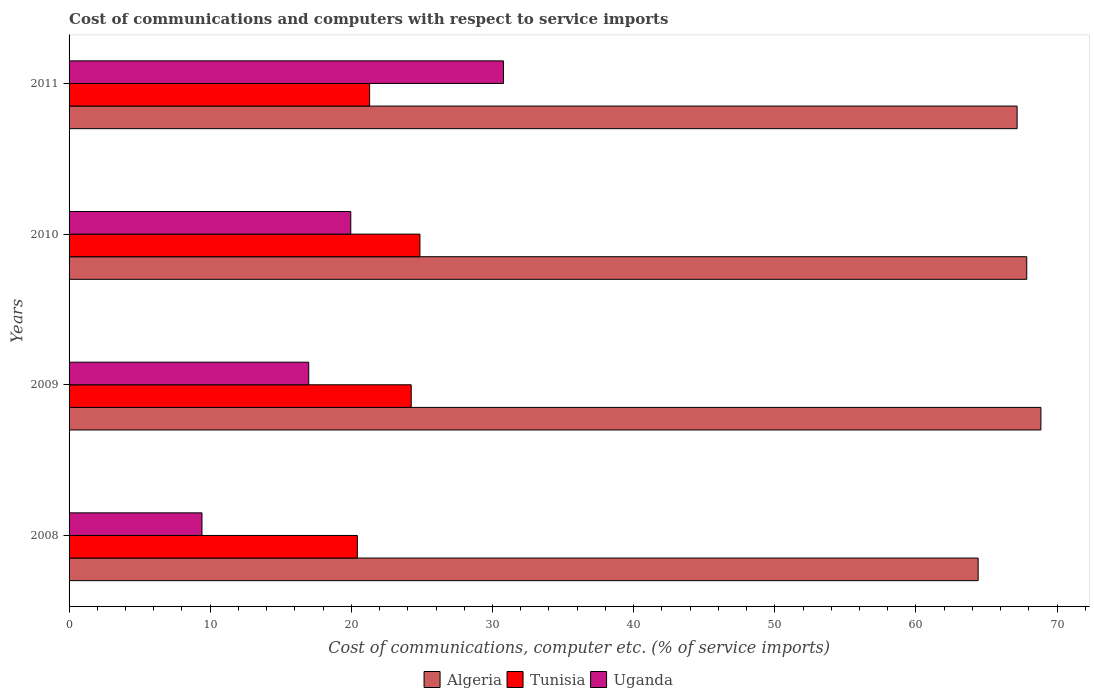How many groups of bars are there?
Your answer should be very brief. 4. How many bars are there on the 4th tick from the bottom?
Make the answer very short. 3. What is the label of the 2nd group of bars from the top?
Your answer should be very brief. 2010. What is the cost of communications and computers in Tunisia in 2011?
Give a very brief answer. 21.29. Across all years, what is the maximum cost of communications and computers in Uganda?
Keep it short and to the point. 30.78. Across all years, what is the minimum cost of communications and computers in Uganda?
Ensure brevity in your answer.  9.42. In which year was the cost of communications and computers in Tunisia maximum?
Provide a succinct answer. 2010. In which year was the cost of communications and computers in Tunisia minimum?
Offer a terse response. 2008. What is the total cost of communications and computers in Uganda in the graph?
Make the answer very short. 77.14. What is the difference between the cost of communications and computers in Tunisia in 2009 and that in 2011?
Provide a short and direct response. 2.95. What is the difference between the cost of communications and computers in Algeria in 2009 and the cost of communications and computers in Uganda in 2008?
Offer a very short reply. 59.44. What is the average cost of communications and computers in Uganda per year?
Your answer should be compact. 19.28. In the year 2011, what is the difference between the cost of communications and computers in Uganda and cost of communications and computers in Tunisia?
Ensure brevity in your answer.  9.48. What is the ratio of the cost of communications and computers in Tunisia in 2008 to that in 2010?
Offer a terse response. 0.82. What is the difference between the highest and the second highest cost of communications and computers in Algeria?
Make the answer very short. 1. What is the difference between the highest and the lowest cost of communications and computers in Algeria?
Give a very brief answer. 4.45. In how many years, is the cost of communications and computers in Algeria greater than the average cost of communications and computers in Algeria taken over all years?
Offer a very short reply. 3. What does the 1st bar from the top in 2009 represents?
Offer a terse response. Uganda. What does the 2nd bar from the bottom in 2009 represents?
Offer a terse response. Tunisia. Is it the case that in every year, the sum of the cost of communications and computers in Algeria and cost of communications and computers in Tunisia is greater than the cost of communications and computers in Uganda?
Your answer should be compact. Yes. Are all the bars in the graph horizontal?
Provide a succinct answer. Yes. How many years are there in the graph?
Offer a very short reply. 4. How many legend labels are there?
Your response must be concise. 3. What is the title of the graph?
Your answer should be very brief. Cost of communications and computers with respect to service imports. What is the label or title of the X-axis?
Make the answer very short. Cost of communications, computer etc. (% of service imports). What is the Cost of communications, computer etc. (% of service imports) of Algeria in 2008?
Provide a short and direct response. 64.41. What is the Cost of communications, computer etc. (% of service imports) of Tunisia in 2008?
Offer a very short reply. 20.42. What is the Cost of communications, computer etc. (% of service imports) of Uganda in 2008?
Your answer should be very brief. 9.42. What is the Cost of communications, computer etc. (% of service imports) in Algeria in 2009?
Provide a short and direct response. 68.86. What is the Cost of communications, computer etc. (% of service imports) of Tunisia in 2009?
Provide a succinct answer. 24.24. What is the Cost of communications, computer etc. (% of service imports) in Uganda in 2009?
Provide a short and direct response. 16.98. What is the Cost of communications, computer etc. (% of service imports) of Algeria in 2010?
Keep it short and to the point. 67.85. What is the Cost of communications, computer etc. (% of service imports) of Tunisia in 2010?
Keep it short and to the point. 24.86. What is the Cost of communications, computer etc. (% of service imports) of Uganda in 2010?
Provide a succinct answer. 19.96. What is the Cost of communications, computer etc. (% of service imports) of Algeria in 2011?
Your answer should be very brief. 67.17. What is the Cost of communications, computer etc. (% of service imports) of Tunisia in 2011?
Make the answer very short. 21.29. What is the Cost of communications, computer etc. (% of service imports) of Uganda in 2011?
Your answer should be very brief. 30.78. Across all years, what is the maximum Cost of communications, computer etc. (% of service imports) of Algeria?
Your response must be concise. 68.86. Across all years, what is the maximum Cost of communications, computer etc. (% of service imports) of Tunisia?
Your answer should be very brief. 24.86. Across all years, what is the maximum Cost of communications, computer etc. (% of service imports) of Uganda?
Your answer should be compact. 30.78. Across all years, what is the minimum Cost of communications, computer etc. (% of service imports) in Algeria?
Offer a terse response. 64.41. Across all years, what is the minimum Cost of communications, computer etc. (% of service imports) of Tunisia?
Offer a terse response. 20.42. Across all years, what is the minimum Cost of communications, computer etc. (% of service imports) in Uganda?
Offer a terse response. 9.42. What is the total Cost of communications, computer etc. (% of service imports) in Algeria in the graph?
Give a very brief answer. 268.29. What is the total Cost of communications, computer etc. (% of service imports) in Tunisia in the graph?
Provide a short and direct response. 90.82. What is the total Cost of communications, computer etc. (% of service imports) of Uganda in the graph?
Offer a terse response. 77.14. What is the difference between the Cost of communications, computer etc. (% of service imports) of Algeria in 2008 and that in 2009?
Provide a succinct answer. -4.45. What is the difference between the Cost of communications, computer etc. (% of service imports) of Tunisia in 2008 and that in 2009?
Make the answer very short. -3.82. What is the difference between the Cost of communications, computer etc. (% of service imports) of Uganda in 2008 and that in 2009?
Ensure brevity in your answer.  -7.56. What is the difference between the Cost of communications, computer etc. (% of service imports) in Algeria in 2008 and that in 2010?
Your response must be concise. -3.44. What is the difference between the Cost of communications, computer etc. (% of service imports) in Tunisia in 2008 and that in 2010?
Your answer should be compact. -4.43. What is the difference between the Cost of communications, computer etc. (% of service imports) of Uganda in 2008 and that in 2010?
Give a very brief answer. -10.54. What is the difference between the Cost of communications, computer etc. (% of service imports) of Algeria in 2008 and that in 2011?
Give a very brief answer. -2.76. What is the difference between the Cost of communications, computer etc. (% of service imports) of Tunisia in 2008 and that in 2011?
Provide a succinct answer. -0.87. What is the difference between the Cost of communications, computer etc. (% of service imports) in Uganda in 2008 and that in 2011?
Make the answer very short. -21.36. What is the difference between the Cost of communications, computer etc. (% of service imports) of Tunisia in 2009 and that in 2010?
Your answer should be very brief. -0.62. What is the difference between the Cost of communications, computer etc. (% of service imports) of Uganda in 2009 and that in 2010?
Your answer should be compact. -2.98. What is the difference between the Cost of communications, computer etc. (% of service imports) in Algeria in 2009 and that in 2011?
Ensure brevity in your answer.  1.69. What is the difference between the Cost of communications, computer etc. (% of service imports) of Tunisia in 2009 and that in 2011?
Make the answer very short. 2.95. What is the difference between the Cost of communications, computer etc. (% of service imports) of Uganda in 2009 and that in 2011?
Provide a succinct answer. -13.8. What is the difference between the Cost of communications, computer etc. (% of service imports) in Algeria in 2010 and that in 2011?
Your answer should be compact. 0.68. What is the difference between the Cost of communications, computer etc. (% of service imports) of Tunisia in 2010 and that in 2011?
Offer a terse response. 3.57. What is the difference between the Cost of communications, computer etc. (% of service imports) of Uganda in 2010 and that in 2011?
Provide a succinct answer. -10.82. What is the difference between the Cost of communications, computer etc. (% of service imports) in Algeria in 2008 and the Cost of communications, computer etc. (% of service imports) in Tunisia in 2009?
Make the answer very short. 40.17. What is the difference between the Cost of communications, computer etc. (% of service imports) in Algeria in 2008 and the Cost of communications, computer etc. (% of service imports) in Uganda in 2009?
Make the answer very short. 47.43. What is the difference between the Cost of communications, computer etc. (% of service imports) of Tunisia in 2008 and the Cost of communications, computer etc. (% of service imports) of Uganda in 2009?
Provide a succinct answer. 3.44. What is the difference between the Cost of communications, computer etc. (% of service imports) in Algeria in 2008 and the Cost of communications, computer etc. (% of service imports) in Tunisia in 2010?
Give a very brief answer. 39.55. What is the difference between the Cost of communications, computer etc. (% of service imports) in Algeria in 2008 and the Cost of communications, computer etc. (% of service imports) in Uganda in 2010?
Ensure brevity in your answer.  44.45. What is the difference between the Cost of communications, computer etc. (% of service imports) of Tunisia in 2008 and the Cost of communications, computer etc. (% of service imports) of Uganda in 2010?
Provide a succinct answer. 0.47. What is the difference between the Cost of communications, computer etc. (% of service imports) of Algeria in 2008 and the Cost of communications, computer etc. (% of service imports) of Tunisia in 2011?
Make the answer very short. 43.12. What is the difference between the Cost of communications, computer etc. (% of service imports) of Algeria in 2008 and the Cost of communications, computer etc. (% of service imports) of Uganda in 2011?
Make the answer very short. 33.63. What is the difference between the Cost of communications, computer etc. (% of service imports) in Tunisia in 2008 and the Cost of communications, computer etc. (% of service imports) in Uganda in 2011?
Offer a very short reply. -10.35. What is the difference between the Cost of communications, computer etc. (% of service imports) of Algeria in 2009 and the Cost of communications, computer etc. (% of service imports) of Tunisia in 2010?
Offer a very short reply. 44. What is the difference between the Cost of communications, computer etc. (% of service imports) in Algeria in 2009 and the Cost of communications, computer etc. (% of service imports) in Uganda in 2010?
Your response must be concise. 48.9. What is the difference between the Cost of communications, computer etc. (% of service imports) in Tunisia in 2009 and the Cost of communications, computer etc. (% of service imports) in Uganda in 2010?
Provide a succinct answer. 4.28. What is the difference between the Cost of communications, computer etc. (% of service imports) of Algeria in 2009 and the Cost of communications, computer etc. (% of service imports) of Tunisia in 2011?
Make the answer very short. 47.56. What is the difference between the Cost of communications, computer etc. (% of service imports) in Algeria in 2009 and the Cost of communications, computer etc. (% of service imports) in Uganda in 2011?
Keep it short and to the point. 38.08. What is the difference between the Cost of communications, computer etc. (% of service imports) in Tunisia in 2009 and the Cost of communications, computer etc. (% of service imports) in Uganda in 2011?
Keep it short and to the point. -6.54. What is the difference between the Cost of communications, computer etc. (% of service imports) of Algeria in 2010 and the Cost of communications, computer etc. (% of service imports) of Tunisia in 2011?
Ensure brevity in your answer.  46.56. What is the difference between the Cost of communications, computer etc. (% of service imports) of Algeria in 2010 and the Cost of communications, computer etc. (% of service imports) of Uganda in 2011?
Provide a succinct answer. 37.07. What is the difference between the Cost of communications, computer etc. (% of service imports) of Tunisia in 2010 and the Cost of communications, computer etc. (% of service imports) of Uganda in 2011?
Provide a short and direct response. -5.92. What is the average Cost of communications, computer etc. (% of service imports) of Algeria per year?
Your answer should be very brief. 67.07. What is the average Cost of communications, computer etc. (% of service imports) in Tunisia per year?
Your answer should be compact. 22.7. What is the average Cost of communications, computer etc. (% of service imports) in Uganda per year?
Ensure brevity in your answer.  19.28. In the year 2008, what is the difference between the Cost of communications, computer etc. (% of service imports) in Algeria and Cost of communications, computer etc. (% of service imports) in Tunisia?
Keep it short and to the point. 43.98. In the year 2008, what is the difference between the Cost of communications, computer etc. (% of service imports) of Algeria and Cost of communications, computer etc. (% of service imports) of Uganda?
Offer a terse response. 54.99. In the year 2008, what is the difference between the Cost of communications, computer etc. (% of service imports) in Tunisia and Cost of communications, computer etc. (% of service imports) in Uganda?
Make the answer very short. 11.01. In the year 2009, what is the difference between the Cost of communications, computer etc. (% of service imports) in Algeria and Cost of communications, computer etc. (% of service imports) in Tunisia?
Give a very brief answer. 44.61. In the year 2009, what is the difference between the Cost of communications, computer etc. (% of service imports) of Algeria and Cost of communications, computer etc. (% of service imports) of Uganda?
Keep it short and to the point. 51.87. In the year 2009, what is the difference between the Cost of communications, computer etc. (% of service imports) in Tunisia and Cost of communications, computer etc. (% of service imports) in Uganda?
Provide a short and direct response. 7.26. In the year 2010, what is the difference between the Cost of communications, computer etc. (% of service imports) in Algeria and Cost of communications, computer etc. (% of service imports) in Tunisia?
Give a very brief answer. 42.99. In the year 2010, what is the difference between the Cost of communications, computer etc. (% of service imports) in Algeria and Cost of communications, computer etc. (% of service imports) in Uganda?
Ensure brevity in your answer.  47.89. In the year 2010, what is the difference between the Cost of communications, computer etc. (% of service imports) in Tunisia and Cost of communications, computer etc. (% of service imports) in Uganda?
Offer a very short reply. 4.9. In the year 2011, what is the difference between the Cost of communications, computer etc. (% of service imports) in Algeria and Cost of communications, computer etc. (% of service imports) in Tunisia?
Your response must be concise. 45.88. In the year 2011, what is the difference between the Cost of communications, computer etc. (% of service imports) of Algeria and Cost of communications, computer etc. (% of service imports) of Uganda?
Your response must be concise. 36.39. In the year 2011, what is the difference between the Cost of communications, computer etc. (% of service imports) of Tunisia and Cost of communications, computer etc. (% of service imports) of Uganda?
Offer a very short reply. -9.48. What is the ratio of the Cost of communications, computer etc. (% of service imports) of Algeria in 2008 to that in 2009?
Provide a short and direct response. 0.94. What is the ratio of the Cost of communications, computer etc. (% of service imports) of Tunisia in 2008 to that in 2009?
Your answer should be very brief. 0.84. What is the ratio of the Cost of communications, computer etc. (% of service imports) of Uganda in 2008 to that in 2009?
Your answer should be compact. 0.55. What is the ratio of the Cost of communications, computer etc. (% of service imports) of Algeria in 2008 to that in 2010?
Offer a terse response. 0.95. What is the ratio of the Cost of communications, computer etc. (% of service imports) of Tunisia in 2008 to that in 2010?
Your response must be concise. 0.82. What is the ratio of the Cost of communications, computer etc. (% of service imports) of Uganda in 2008 to that in 2010?
Provide a succinct answer. 0.47. What is the ratio of the Cost of communications, computer etc. (% of service imports) of Algeria in 2008 to that in 2011?
Give a very brief answer. 0.96. What is the ratio of the Cost of communications, computer etc. (% of service imports) of Tunisia in 2008 to that in 2011?
Keep it short and to the point. 0.96. What is the ratio of the Cost of communications, computer etc. (% of service imports) of Uganda in 2008 to that in 2011?
Ensure brevity in your answer.  0.31. What is the ratio of the Cost of communications, computer etc. (% of service imports) in Algeria in 2009 to that in 2010?
Provide a succinct answer. 1.01. What is the ratio of the Cost of communications, computer etc. (% of service imports) in Tunisia in 2009 to that in 2010?
Offer a very short reply. 0.98. What is the ratio of the Cost of communications, computer etc. (% of service imports) in Uganda in 2009 to that in 2010?
Offer a very short reply. 0.85. What is the ratio of the Cost of communications, computer etc. (% of service imports) in Algeria in 2009 to that in 2011?
Keep it short and to the point. 1.03. What is the ratio of the Cost of communications, computer etc. (% of service imports) in Tunisia in 2009 to that in 2011?
Give a very brief answer. 1.14. What is the ratio of the Cost of communications, computer etc. (% of service imports) in Uganda in 2009 to that in 2011?
Make the answer very short. 0.55. What is the ratio of the Cost of communications, computer etc. (% of service imports) in Algeria in 2010 to that in 2011?
Your response must be concise. 1.01. What is the ratio of the Cost of communications, computer etc. (% of service imports) of Tunisia in 2010 to that in 2011?
Make the answer very short. 1.17. What is the ratio of the Cost of communications, computer etc. (% of service imports) in Uganda in 2010 to that in 2011?
Your response must be concise. 0.65. What is the difference between the highest and the second highest Cost of communications, computer etc. (% of service imports) of Tunisia?
Ensure brevity in your answer.  0.62. What is the difference between the highest and the second highest Cost of communications, computer etc. (% of service imports) in Uganda?
Offer a terse response. 10.82. What is the difference between the highest and the lowest Cost of communications, computer etc. (% of service imports) in Algeria?
Offer a terse response. 4.45. What is the difference between the highest and the lowest Cost of communications, computer etc. (% of service imports) in Tunisia?
Give a very brief answer. 4.43. What is the difference between the highest and the lowest Cost of communications, computer etc. (% of service imports) in Uganda?
Provide a short and direct response. 21.36. 